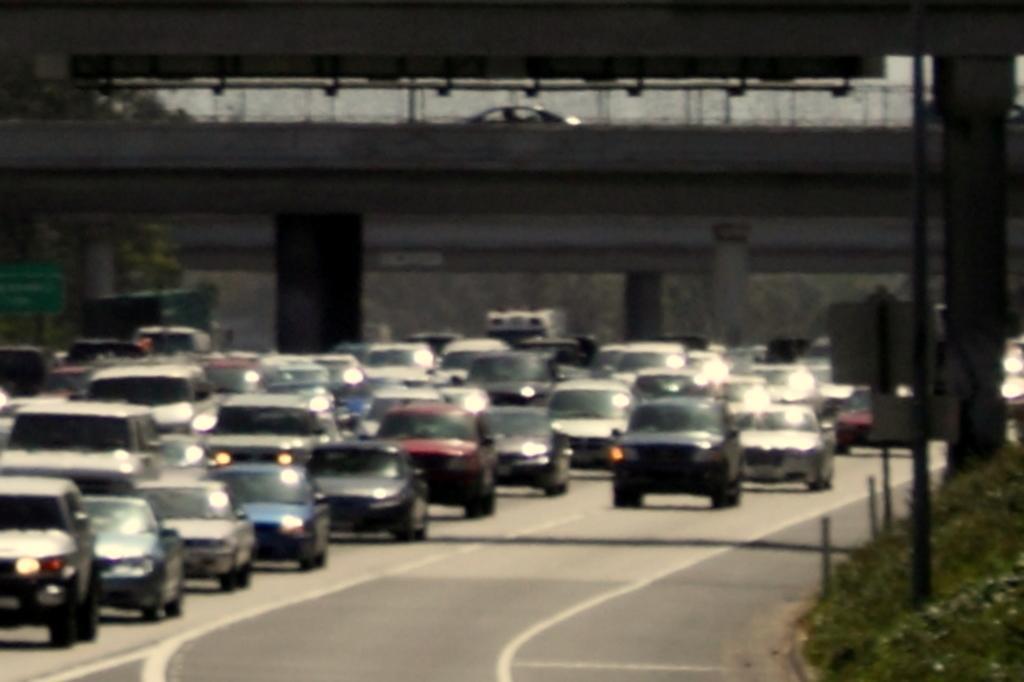Describe this image in one or two sentences. In the picture we can see a road and a number of cars on it and besides the road we can see a grass surface and some poles on it with some boards and in the background, we can see a bridge and a car on it and to the bridge we can see some pillars. 